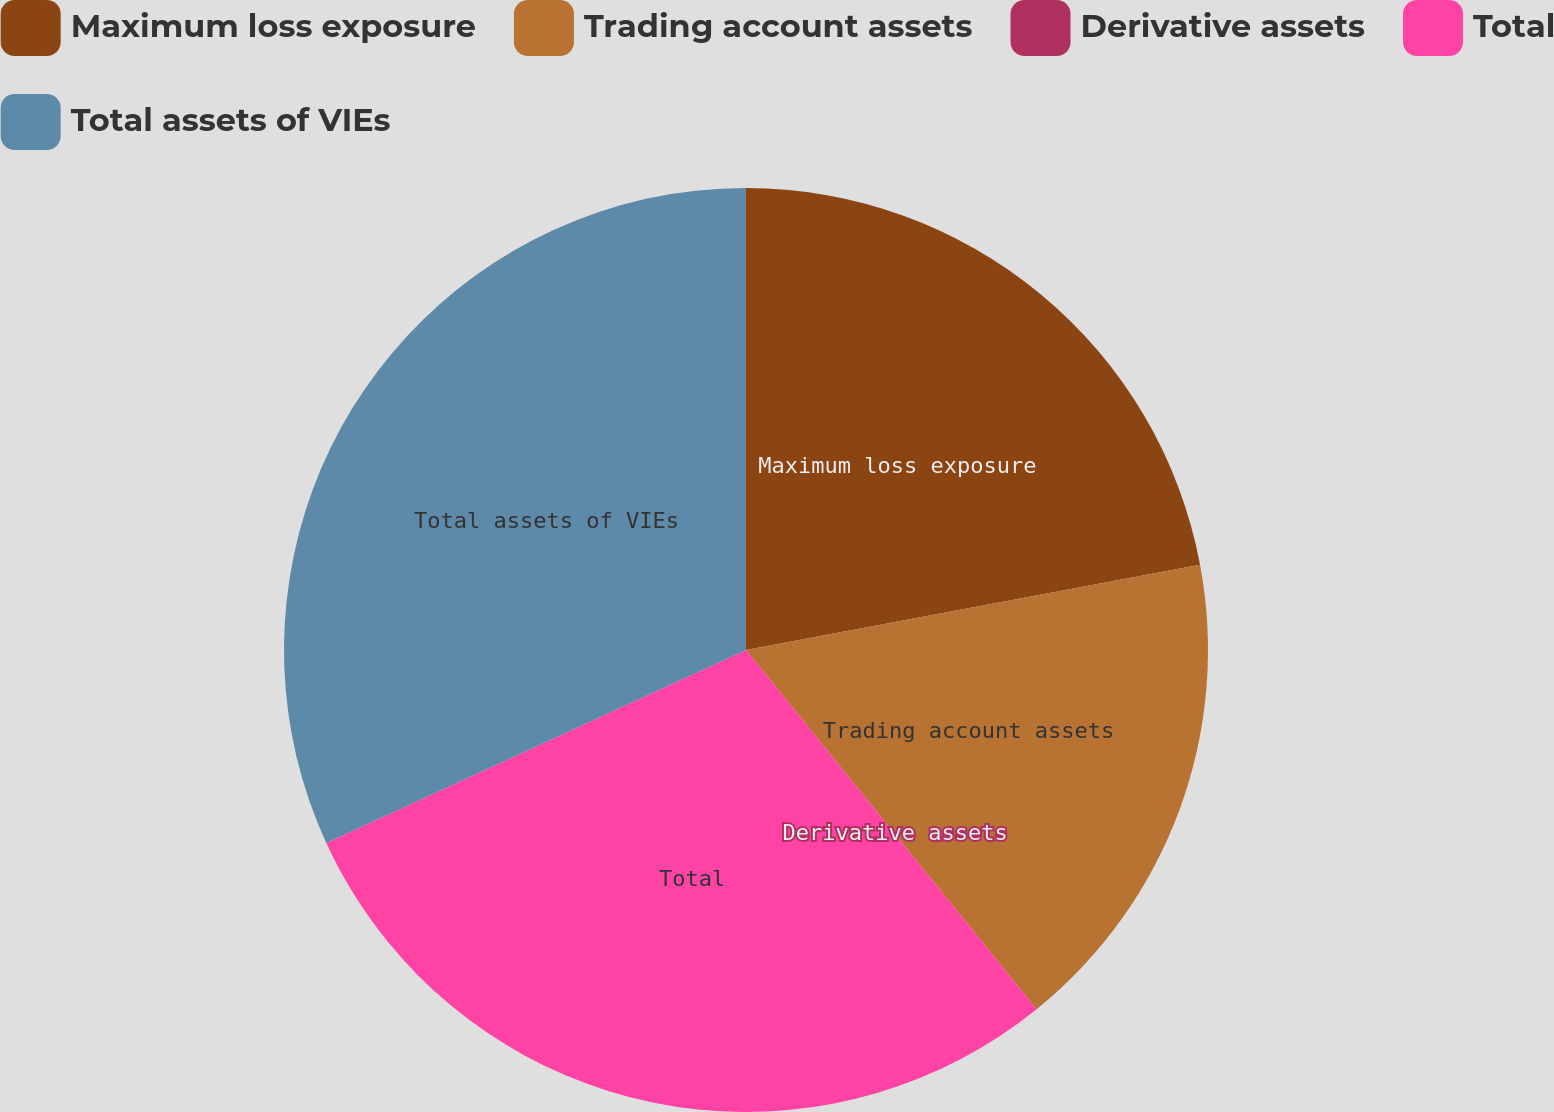Convert chart to OTSL. <chart><loc_0><loc_0><loc_500><loc_500><pie_chart><fcel>Maximum loss exposure<fcel>Trading account assets<fcel>Derivative assets<fcel>Total<fcel>Total assets of VIEs<nl><fcel>22.04%<fcel>17.13%<fcel>0.0%<fcel>28.96%<fcel>31.86%<nl></chart> 